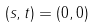<formula> <loc_0><loc_0><loc_500><loc_500>( s , t ) = ( 0 , 0 )</formula> 